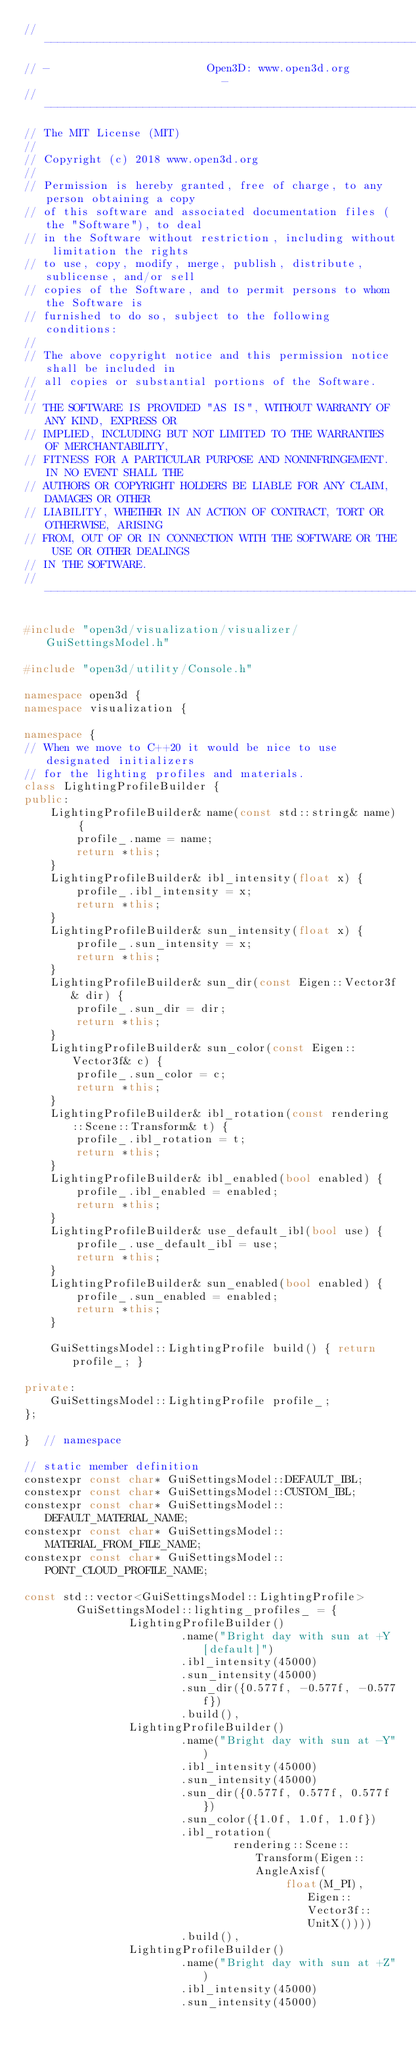<code> <loc_0><loc_0><loc_500><loc_500><_C++_>// ----------------------------------------------------------------------------
// -                        Open3D: www.open3d.org                            -
// ----------------------------------------------------------------------------
// The MIT License (MIT)
//
// Copyright (c) 2018 www.open3d.org
//
// Permission is hereby granted, free of charge, to any person obtaining a copy
// of this software and associated documentation files (the "Software"), to deal
// in the Software without restriction, including without limitation the rights
// to use, copy, modify, merge, publish, distribute, sublicense, and/or sell
// copies of the Software, and to permit persons to whom the Software is
// furnished to do so, subject to the following conditions:
//
// The above copyright notice and this permission notice shall be included in
// all copies or substantial portions of the Software.
//
// THE SOFTWARE IS PROVIDED "AS IS", WITHOUT WARRANTY OF ANY KIND, EXPRESS OR
// IMPLIED, INCLUDING BUT NOT LIMITED TO THE WARRANTIES OF MERCHANTABILITY,
// FITNESS FOR A PARTICULAR PURPOSE AND NONINFRINGEMENT. IN NO EVENT SHALL THE
// AUTHORS OR COPYRIGHT HOLDERS BE LIABLE FOR ANY CLAIM, DAMAGES OR OTHER
// LIABILITY, WHETHER IN AN ACTION OF CONTRACT, TORT OR OTHERWISE, ARISING
// FROM, OUT OF OR IN CONNECTION WITH THE SOFTWARE OR THE USE OR OTHER DEALINGS
// IN THE SOFTWARE.
// ----------------------------------------------------------------------------

#include "open3d/visualization/visualizer/GuiSettingsModel.h"

#include "open3d/utility/Console.h"

namespace open3d {
namespace visualization {

namespace {
// When we move to C++20 it would be nice to use designated initializers
// for the lighting profiles and materials.
class LightingProfileBuilder {
public:
    LightingProfileBuilder& name(const std::string& name) {
        profile_.name = name;
        return *this;
    }
    LightingProfileBuilder& ibl_intensity(float x) {
        profile_.ibl_intensity = x;
        return *this;
    }
    LightingProfileBuilder& sun_intensity(float x) {
        profile_.sun_intensity = x;
        return *this;
    }
    LightingProfileBuilder& sun_dir(const Eigen::Vector3f& dir) {
        profile_.sun_dir = dir;
        return *this;
    }
    LightingProfileBuilder& sun_color(const Eigen::Vector3f& c) {
        profile_.sun_color = c;
        return *this;
    }
    LightingProfileBuilder& ibl_rotation(const rendering::Scene::Transform& t) {
        profile_.ibl_rotation = t;
        return *this;
    }
    LightingProfileBuilder& ibl_enabled(bool enabled) {
        profile_.ibl_enabled = enabled;
        return *this;
    }
    LightingProfileBuilder& use_default_ibl(bool use) {
        profile_.use_default_ibl = use;
        return *this;
    }
    LightingProfileBuilder& sun_enabled(bool enabled) {
        profile_.sun_enabled = enabled;
        return *this;
    }

    GuiSettingsModel::LightingProfile build() { return profile_; }

private:
    GuiSettingsModel::LightingProfile profile_;
};

}  // namespace

// static member definition
constexpr const char* GuiSettingsModel::DEFAULT_IBL;
constexpr const char* GuiSettingsModel::CUSTOM_IBL;
constexpr const char* GuiSettingsModel::DEFAULT_MATERIAL_NAME;
constexpr const char* GuiSettingsModel::MATERIAL_FROM_FILE_NAME;
constexpr const char* GuiSettingsModel::POINT_CLOUD_PROFILE_NAME;

const std::vector<GuiSettingsModel::LightingProfile>
        GuiSettingsModel::lighting_profiles_ = {
                LightingProfileBuilder()
                        .name("Bright day with sun at +Y [default]")
                        .ibl_intensity(45000)
                        .sun_intensity(45000)
                        .sun_dir({0.577f, -0.577f, -0.577f})
                        .build(),
                LightingProfileBuilder()
                        .name("Bright day with sun at -Y")
                        .ibl_intensity(45000)
                        .sun_intensity(45000)
                        .sun_dir({0.577f, 0.577f, 0.577f})
                        .sun_color({1.0f, 1.0f, 1.0f})
                        .ibl_rotation(
                                rendering::Scene::Transform(Eigen::AngleAxisf(
                                        float(M_PI), Eigen::Vector3f::UnitX())))
                        .build(),
                LightingProfileBuilder()
                        .name("Bright day with sun at +Z")
                        .ibl_intensity(45000)
                        .sun_intensity(45000)</code> 